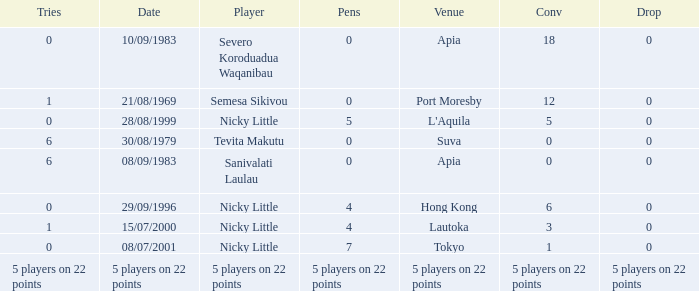How many conversions did Severo Koroduadua Waqanibau have when he has 0 pens? 18.0. 